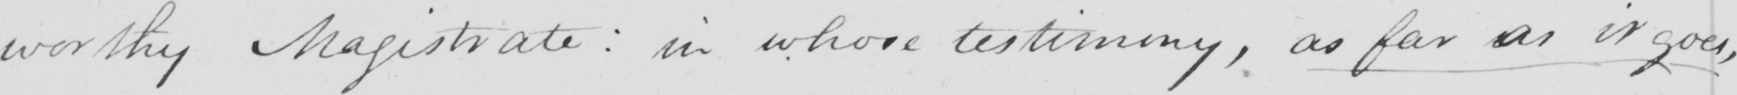Please provide the text content of this handwritten line. worthy Magistrate :  in whose testimony , as far as it goes , 